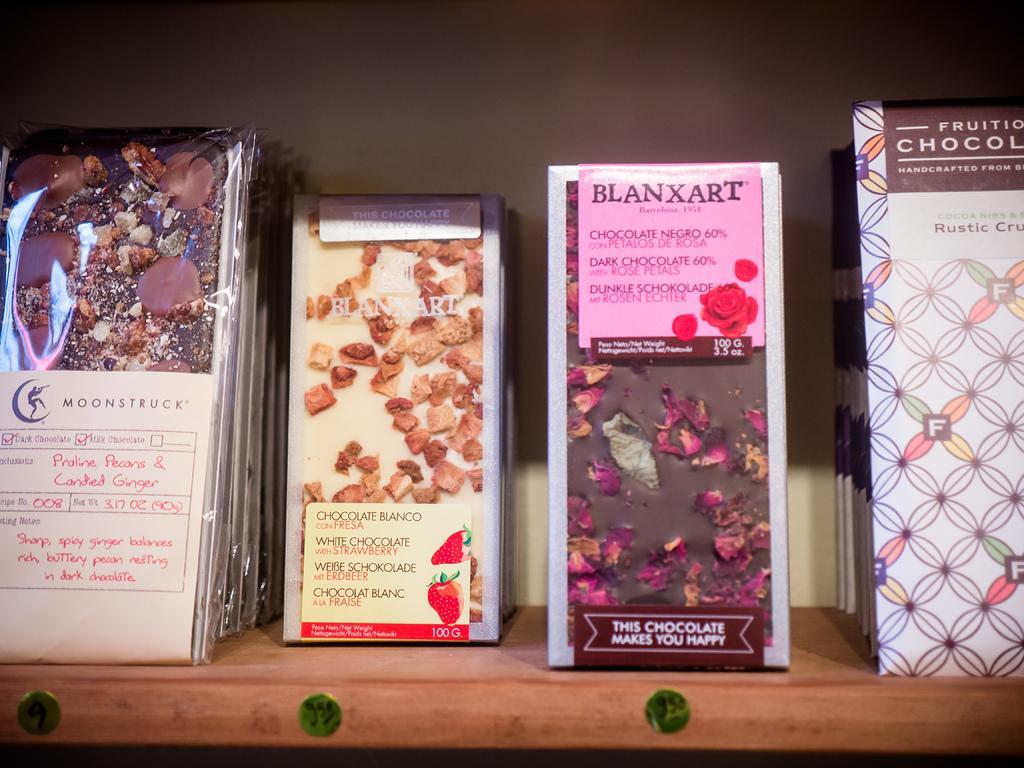Can you describe this image briefly? The picture consists of various chocolates in wrappers. The chocolates are placed in a wooden shelf. In the background it is well. 